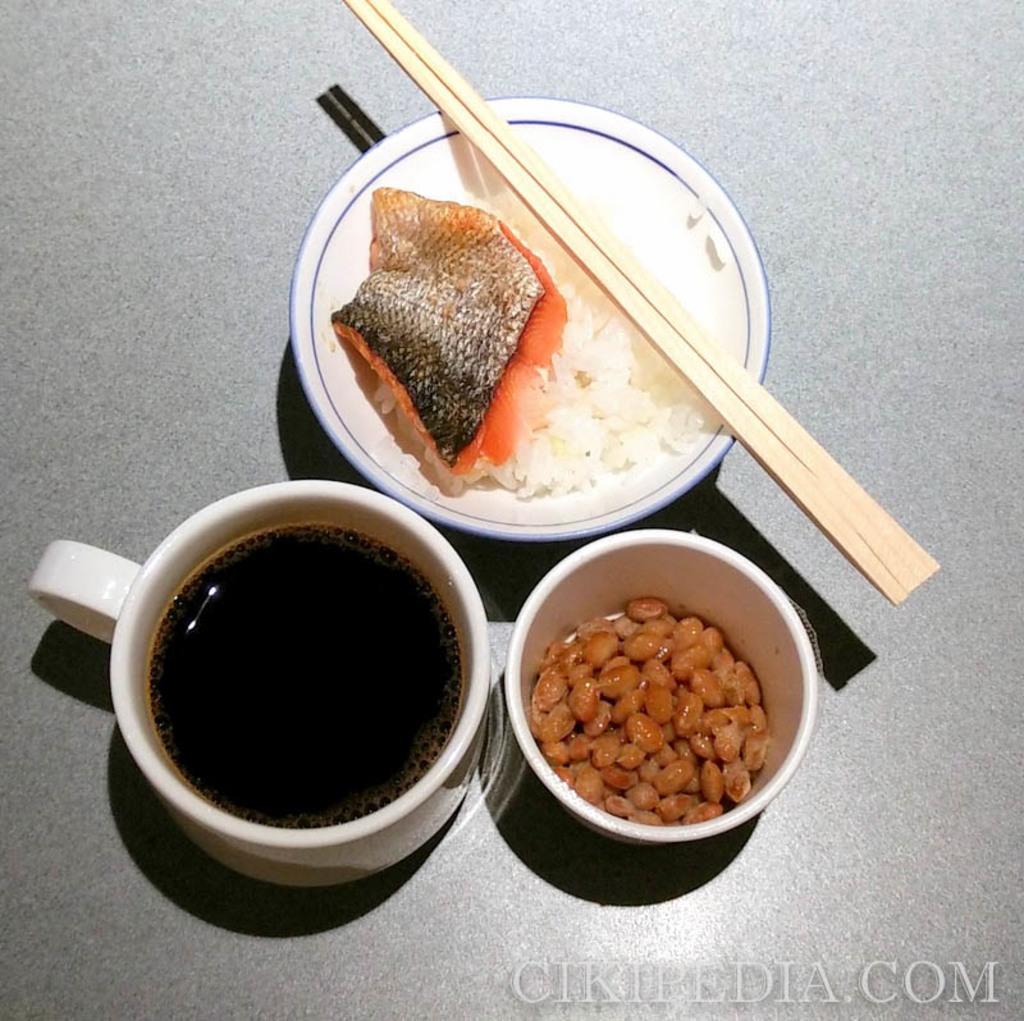Could you give a brief overview of what you see in this image? In this image I can see two bowls having some food items in it and one cup having some drink in it and also there are two chop sticks. 